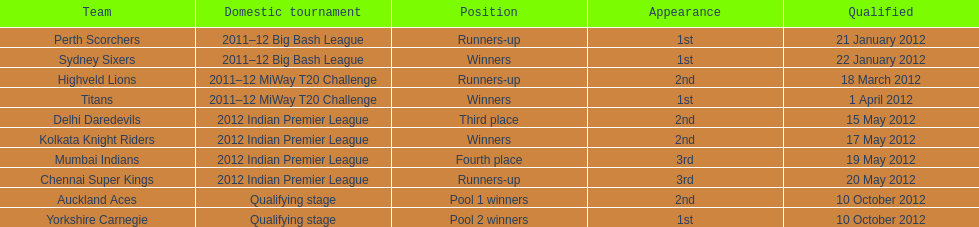Did the titans or the daredevils winners? Titans. 